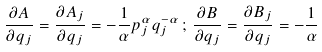Convert formula to latex. <formula><loc_0><loc_0><loc_500><loc_500>\frac { \partial A } { \partial q _ { j } } = \frac { \partial A _ { j } } { \partial q _ { j } } = - \frac { 1 } { \alpha } p ^ { \alpha } _ { j } q ^ { - \alpha } _ { j } \, ; \, \frac { \partial B } { \partial q _ { j } } = \frac { \partial B _ { j } } { \partial q _ { j } } = - \frac { 1 } { \alpha }</formula> 